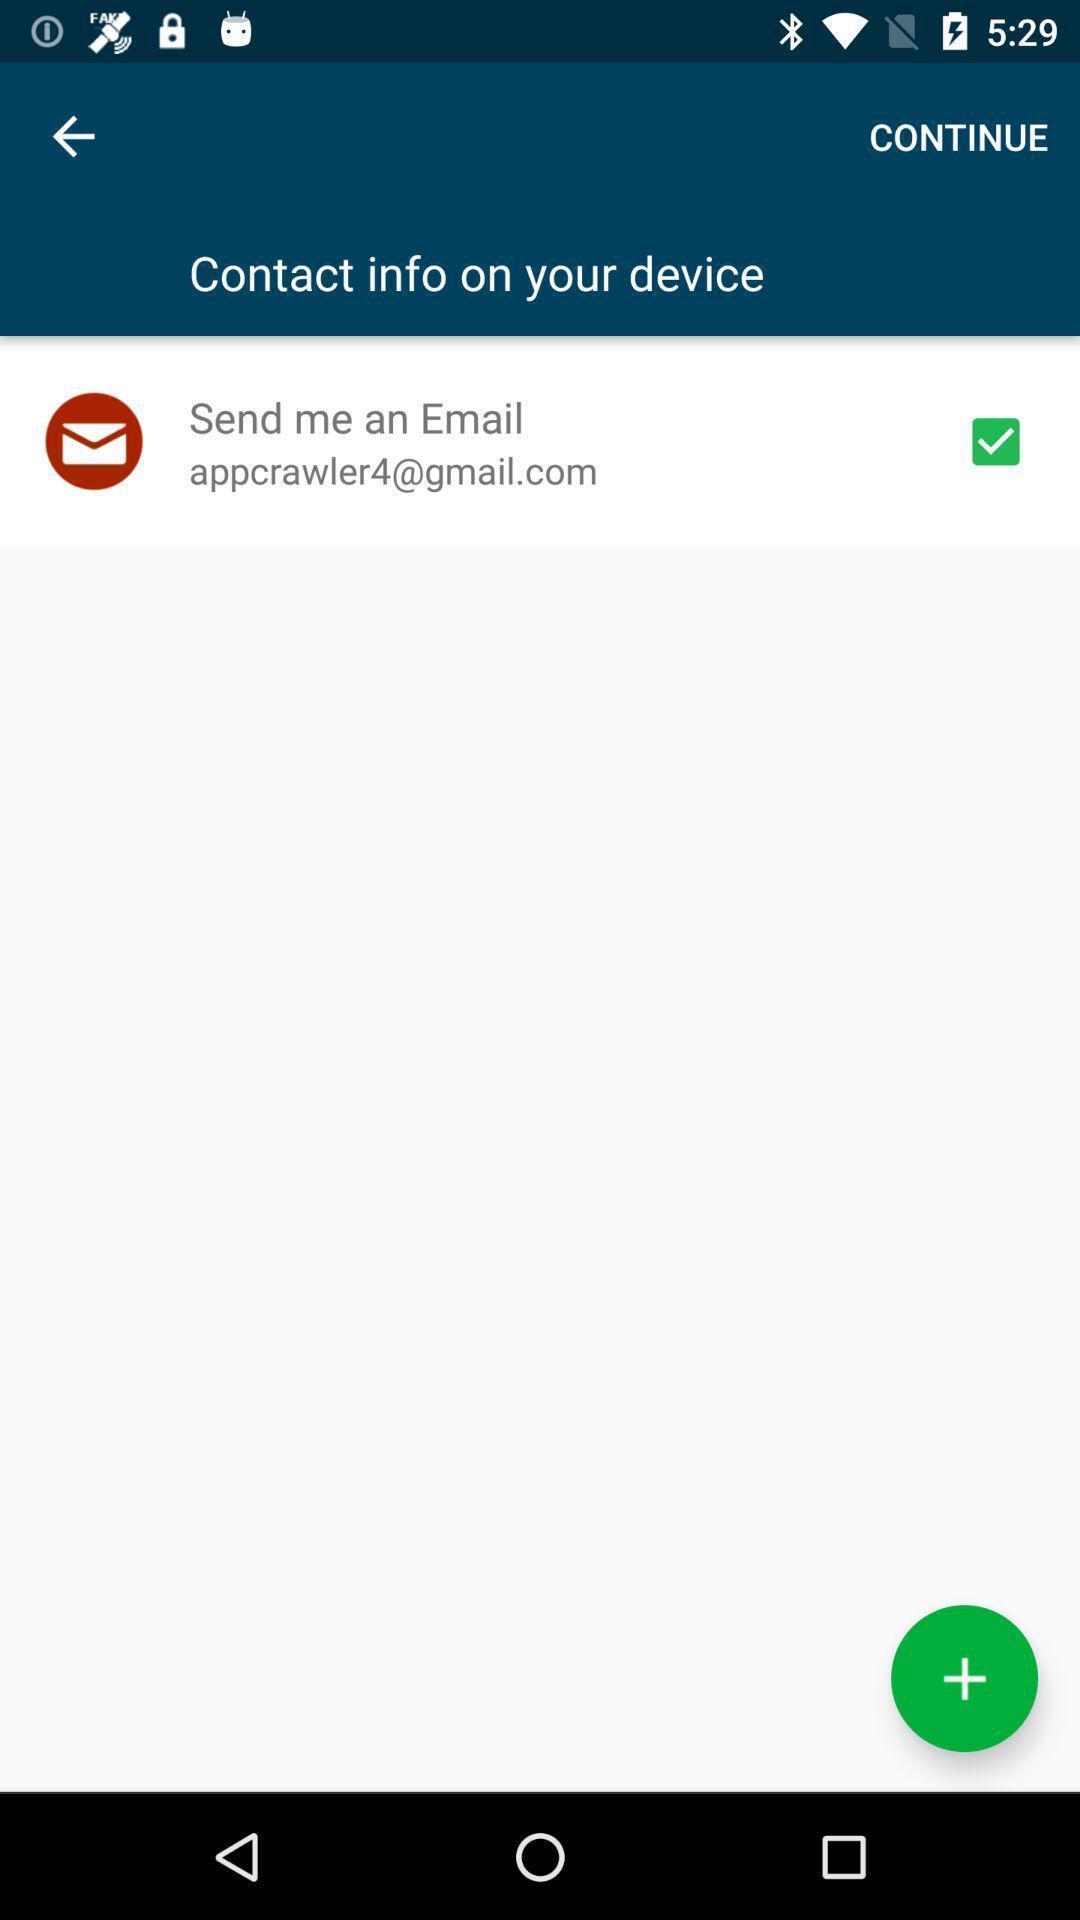Describe this image in words. Screen shows contact info. 